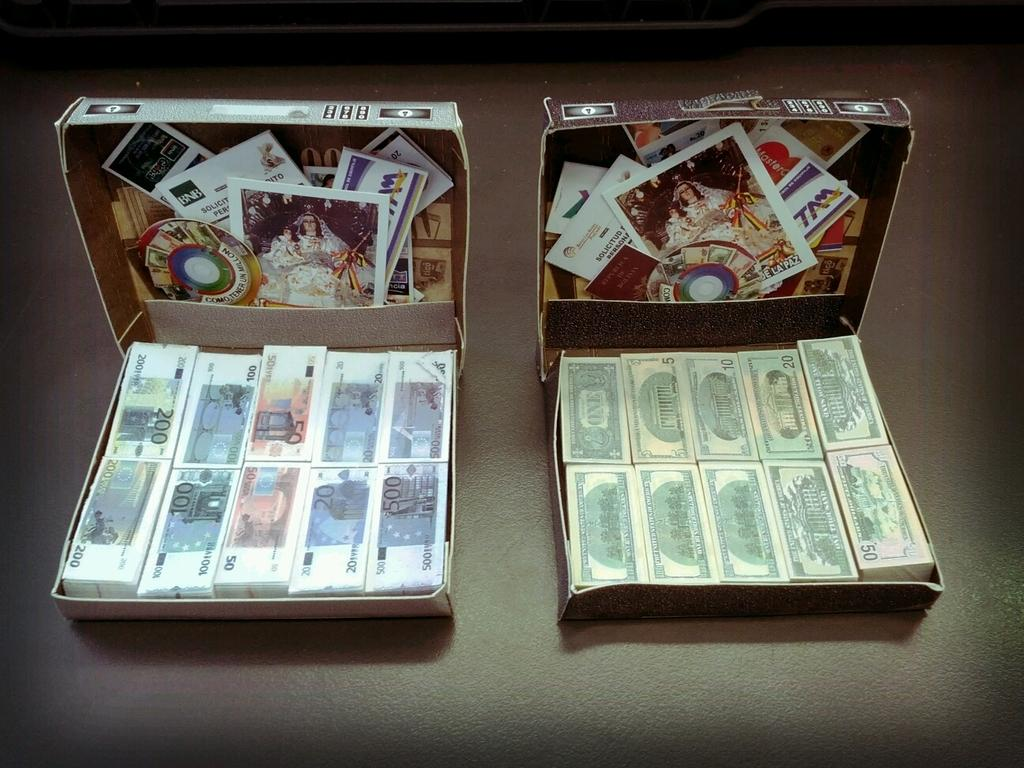<image>
Create a compact narrative representing the image presented. Boxes of money including five and ten dollar bills are opened for display. 